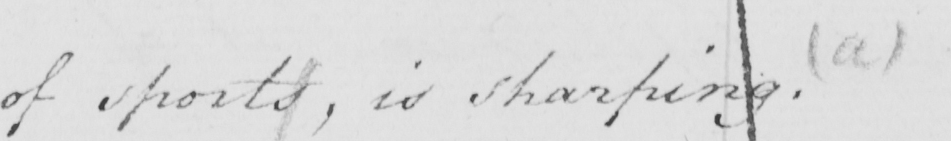What text is written in this handwritten line? of sports , is sharping .  ( a ) 